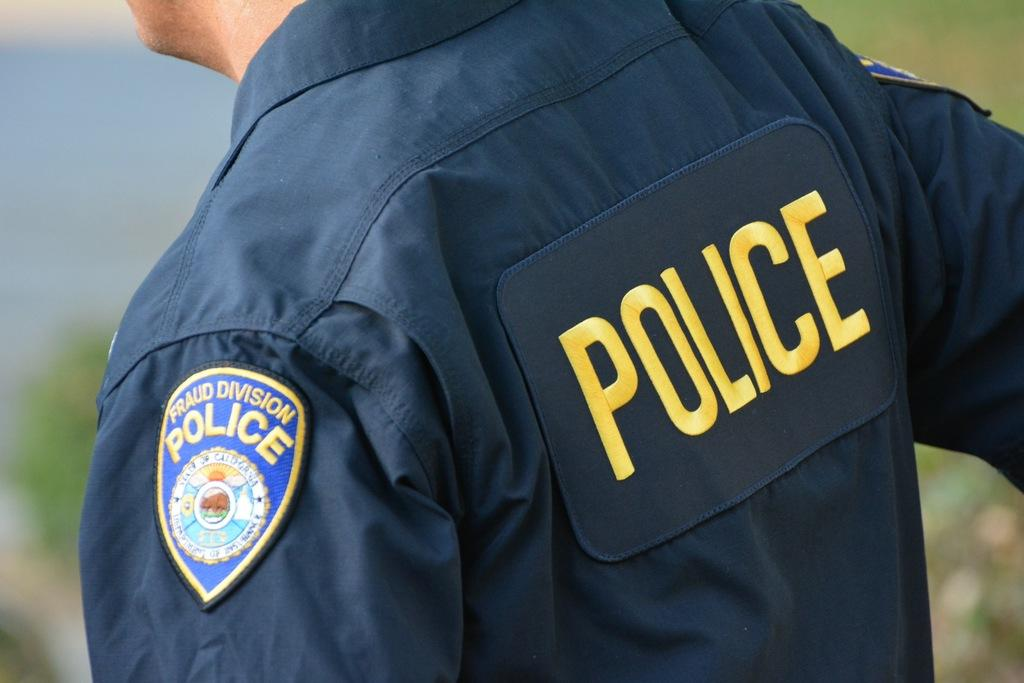<image>
Share a concise interpretation of the image provided. A man with the word POLICE written in yellow on his back. 